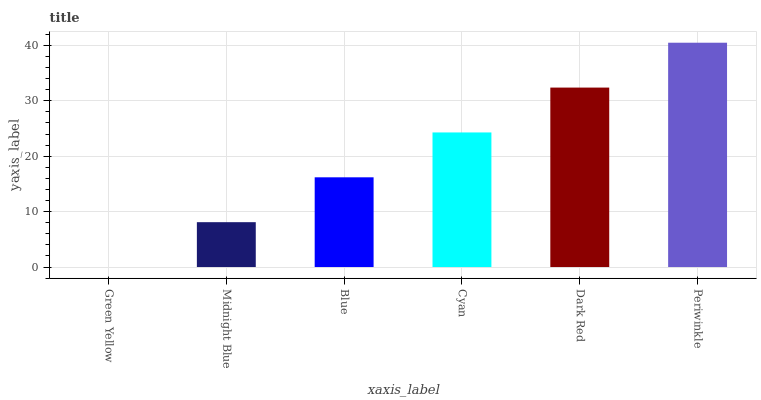Is Green Yellow the minimum?
Answer yes or no. Yes. Is Periwinkle the maximum?
Answer yes or no. Yes. Is Midnight Blue the minimum?
Answer yes or no. No. Is Midnight Blue the maximum?
Answer yes or no. No. Is Midnight Blue greater than Green Yellow?
Answer yes or no. Yes. Is Green Yellow less than Midnight Blue?
Answer yes or no. Yes. Is Green Yellow greater than Midnight Blue?
Answer yes or no. No. Is Midnight Blue less than Green Yellow?
Answer yes or no. No. Is Cyan the high median?
Answer yes or no. Yes. Is Blue the low median?
Answer yes or no. Yes. Is Green Yellow the high median?
Answer yes or no. No. Is Dark Red the low median?
Answer yes or no. No. 